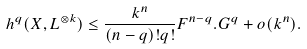Convert formula to latex. <formula><loc_0><loc_0><loc_500><loc_500>h ^ { q } ( X , L ^ { \otimes k } ) \leq \frac { k ^ { n } } { ( n - q ) ! q ! } F ^ { n - q } . G ^ { q } + o ( k ^ { n } ) .</formula> 